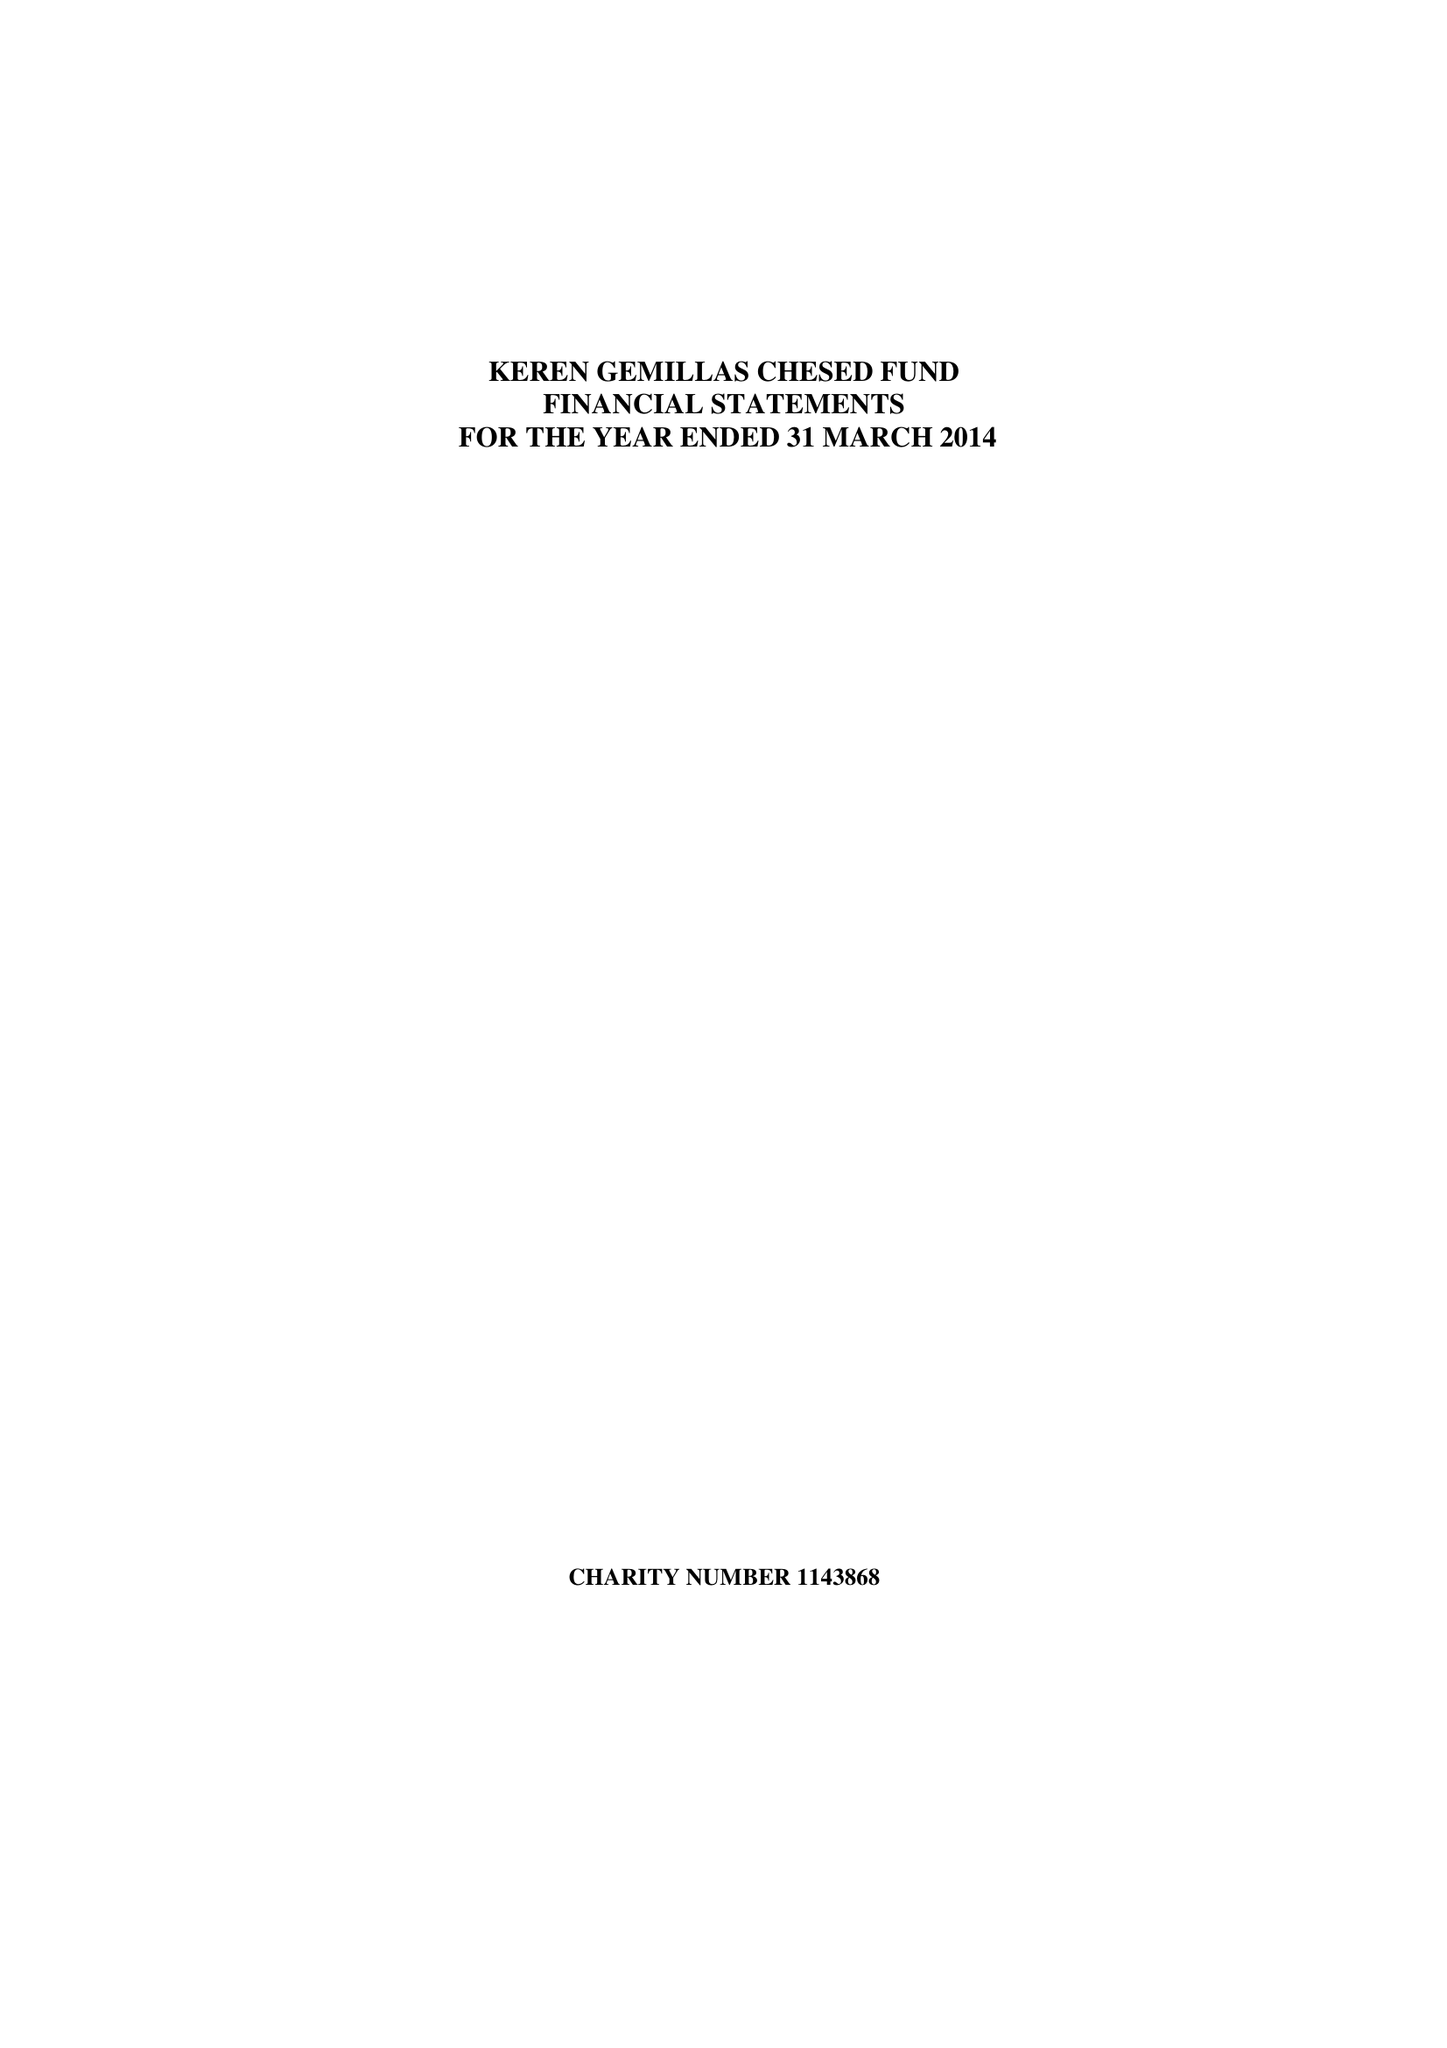What is the value for the address__street_line?
Answer the question using a single word or phrase. None 